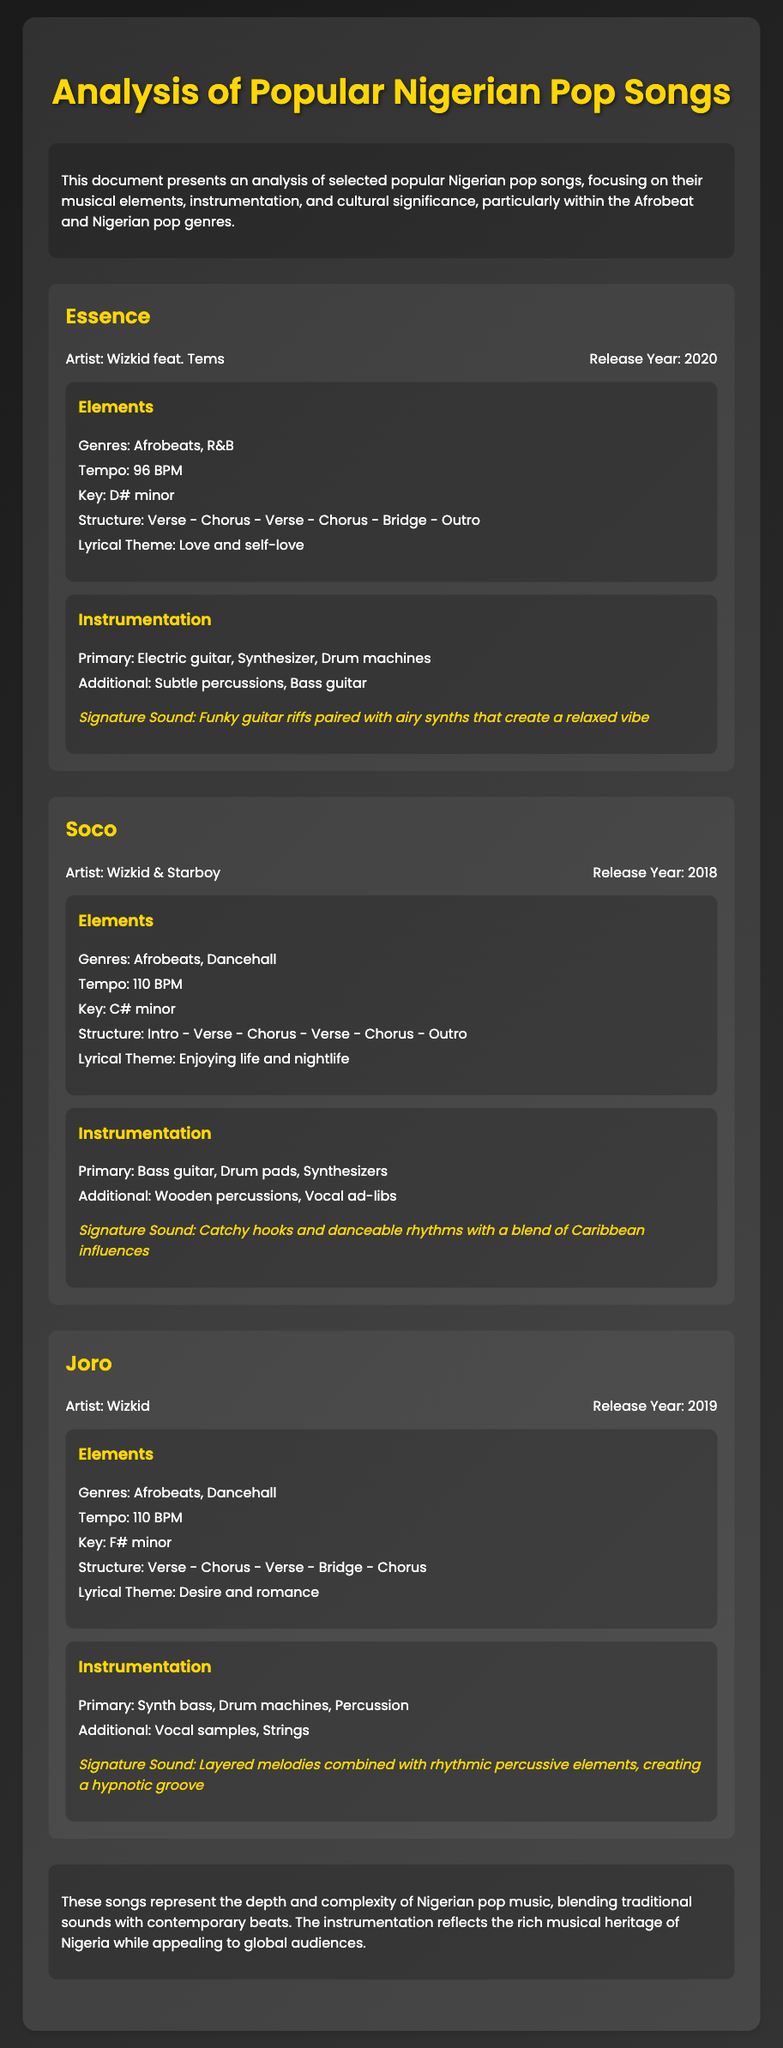What is the title of the document? The title of the document is located at the top and introduces the main topic of analysis.
Answer: Analysis of Popular Nigerian Pop Songs Who are the featured artists on the song "Essence"? The document lists the artists for each song, which are mentioned in the song section.
Answer: Wizkid feat. Tems What is the release year of "Soco"? The release year for each song is specified in the song information section.
Answer: 2018 What is the tempo of "Joro"? The tempo is noted as BPM (beats per minute) in the elements section of each song.
Answer: 110 BPM What is the lyrical theme of "Essence"? The lyrical theme is highlighted in the elements section for each song.
Answer: Love and self-love Which instrument is highlighted as primary in "Soco"? The primary instruments are listed in the instrumentation section of each song.
Answer: Bass guitar How many songs are analyzed in the document? The document provides sections for a specific number of songs that are analyzed.
Answer: Three What genre does "Joro" belong to? The genres are specified in the elements section for each song.
Answer: Afrobeats, Dancehall What is the signature sound of "Essence"? The signature sound is described in a specific sentence within the instrumentation section of each song.
Answer: Funky guitar riffs paired with airy synths that create a relaxed vibe 